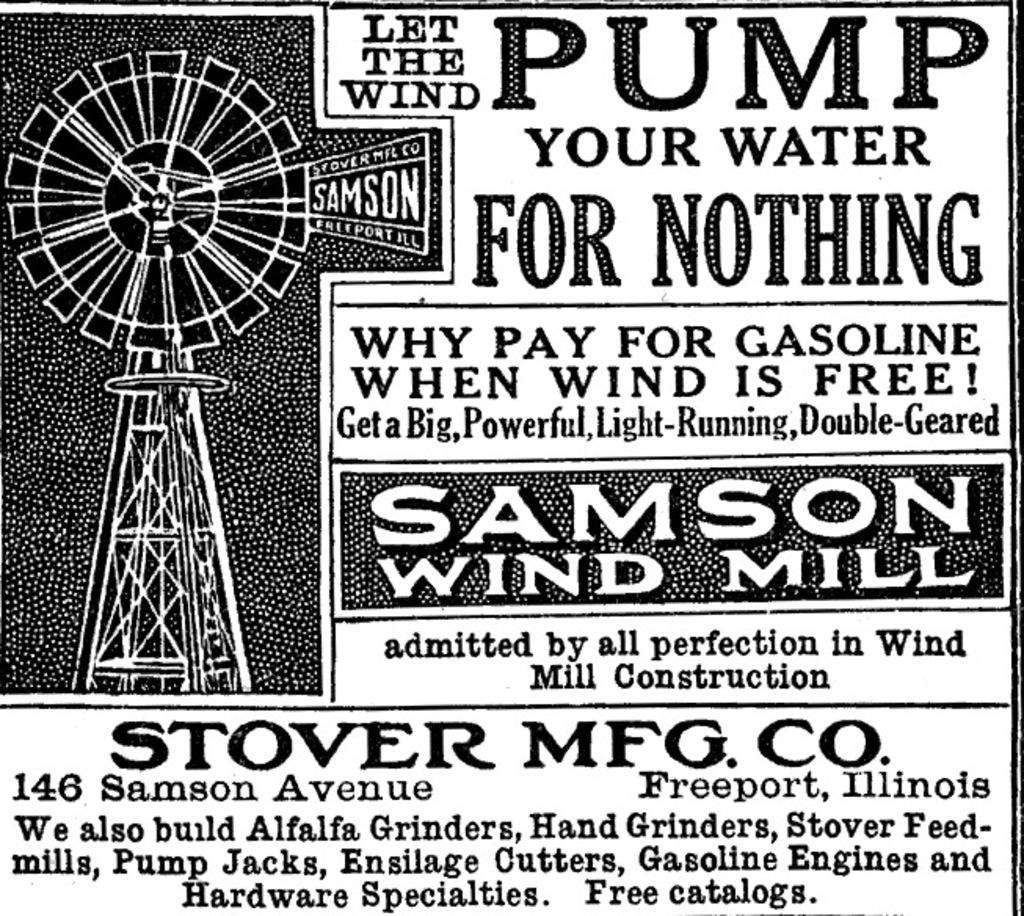<image>
Render a clear and concise summary of the photo. A black and white vintage poster for Samson Wind Mill. 